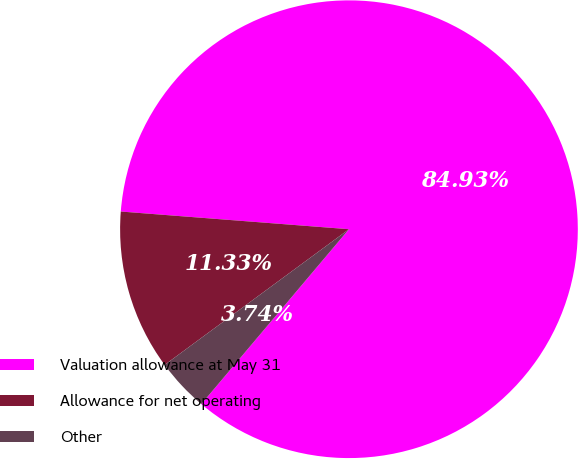Convert chart to OTSL. <chart><loc_0><loc_0><loc_500><loc_500><pie_chart><fcel>Valuation allowance at May 31<fcel>Allowance for net operating<fcel>Other<nl><fcel>84.92%<fcel>11.33%<fcel>3.74%<nl></chart> 